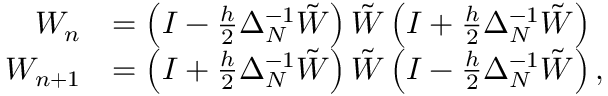Convert formula to latex. <formula><loc_0><loc_0><loc_500><loc_500>\begin{array} { r l } { W _ { n } } & { = \left ( I - \frac { h } { 2 } \Delta _ { N } ^ { - 1 } \tilde { W } \right ) \tilde { W } \left ( I + \frac { h } { 2 } \Delta _ { N } ^ { - 1 } \tilde { W } \right ) } \\ { W _ { n + 1 } } & { = \left ( I + \frac { h } { 2 } \Delta _ { N } ^ { - 1 } \tilde { W } \right ) \tilde { W } \left ( I - \frac { h } { 2 } \Delta _ { N } ^ { - 1 } \tilde { W } \right ) , } \end{array}</formula> 